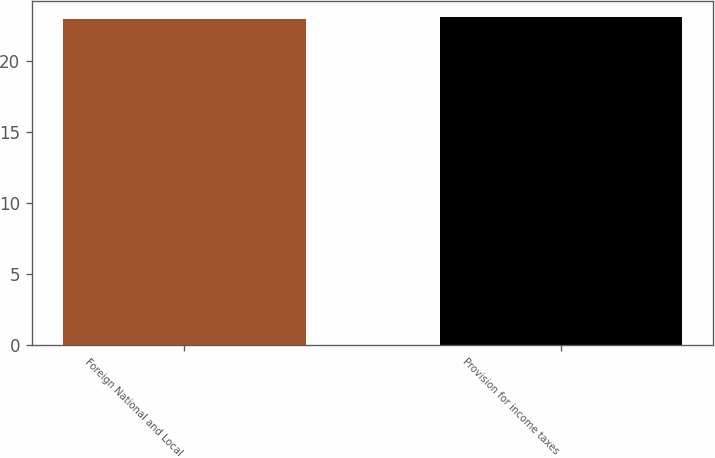Convert chart. <chart><loc_0><loc_0><loc_500><loc_500><bar_chart><fcel>Foreign National and Local<fcel>Provision for income taxes<nl><fcel>23<fcel>23.1<nl></chart> 